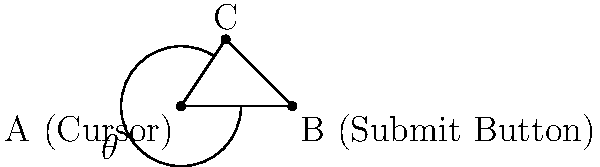You're trying to post a comment, but it's not appearing. Frustrated, you notice your cursor is at point A, and the submit button is at point B. If the angle between your cursor and the submit button is $\theta$, and the distance AC is 3 units while AB is 5 units, what is the value of $\theta$ in degrees? Let's approach this step-by-step:

1) We have a right-angled triangle ABC, where:
   - A is the cursor position
   - B is the submit button position
   - C is the point where AC is perpendicular to AB

2) We know that:
   - AC = 3 units
   - AB = 5 units

3) In a right-angled triangle, we can use the cosine function to find the angle:

   $\cos \theta = \frac{\text{adjacent}}{\text{hypotenuse}} = \frac{AB}{AC}$

4) Plugging in our known values:

   $\cos \theta = \frac{5}{3}$

5) To find $\theta$, we need to take the inverse cosine (arccos) of both sides:

   $\theta = \arccos(\frac{5}{3})$

6) Using a calculator or computer, we can evaluate this:

   $\theta \approx 0.9272952180 \text{ radians}$

7) To convert to degrees, multiply by $\frac{180}{\pi}$:

   $\theta \approx 0.9272952180 \times \frac{180}{\pi} \approx 53.13010235^\circ$

8) Rounding to the nearest degree:

   $\theta \approx 53^\circ$
Answer: $53^\circ$ 